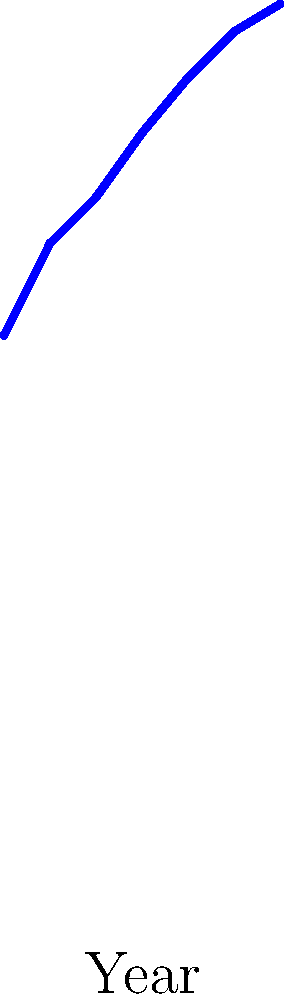Based on the graph showing the improvement in image recognition accuracy for country album covers over time, what is the approximate accuracy percentage achieved by 2020, and how might this technology benefit a devoted country music fan in organizing their album collection? To answer this question, let's break it down step-by-step:

1. Interpret the graph:
   - The x-axis represents years from 1990 to 2020.
   - The y-axis represents accuracy percentage for image recognition of country album covers.
   - The blue line shows the trend of improving accuracy over time.

2. Identify the accuracy for 2020:
   - Looking at the rightmost point on the graph, we can see that it corresponds to the year 2020.
   - The y-value for this point is approximately 96%.

3. Consider the benefits for a country music fan:
   a) Automatic organization: With 96% accuracy, the technology could automatically sort and categorize album covers by artist, making it easier to manage large collections.
   b) Quick search: Fans could use image recognition to quickly find specific albums or artists in their collection by taking a photo of an album cover.
   c) Recommendation systems: The technology could analyze album cover styles to suggest similar artists or albums.
   d) Authenticity verification: High accuracy could help identify counterfeit or mislabeled albums in a collection.
   e) Digital archiving: Fans could easily digitize their physical collection, maintaining a searchable database of their albums.

4. Specific benefit for a Patty Loveless fan:
   - The technology could quickly identify all Patty Loveless albums in a large collection, helping to ensure the collection is complete and properly organized.
Answer: 96% accuracy; enables automatic organization, quick searches, and improved management of large country music album collections. 